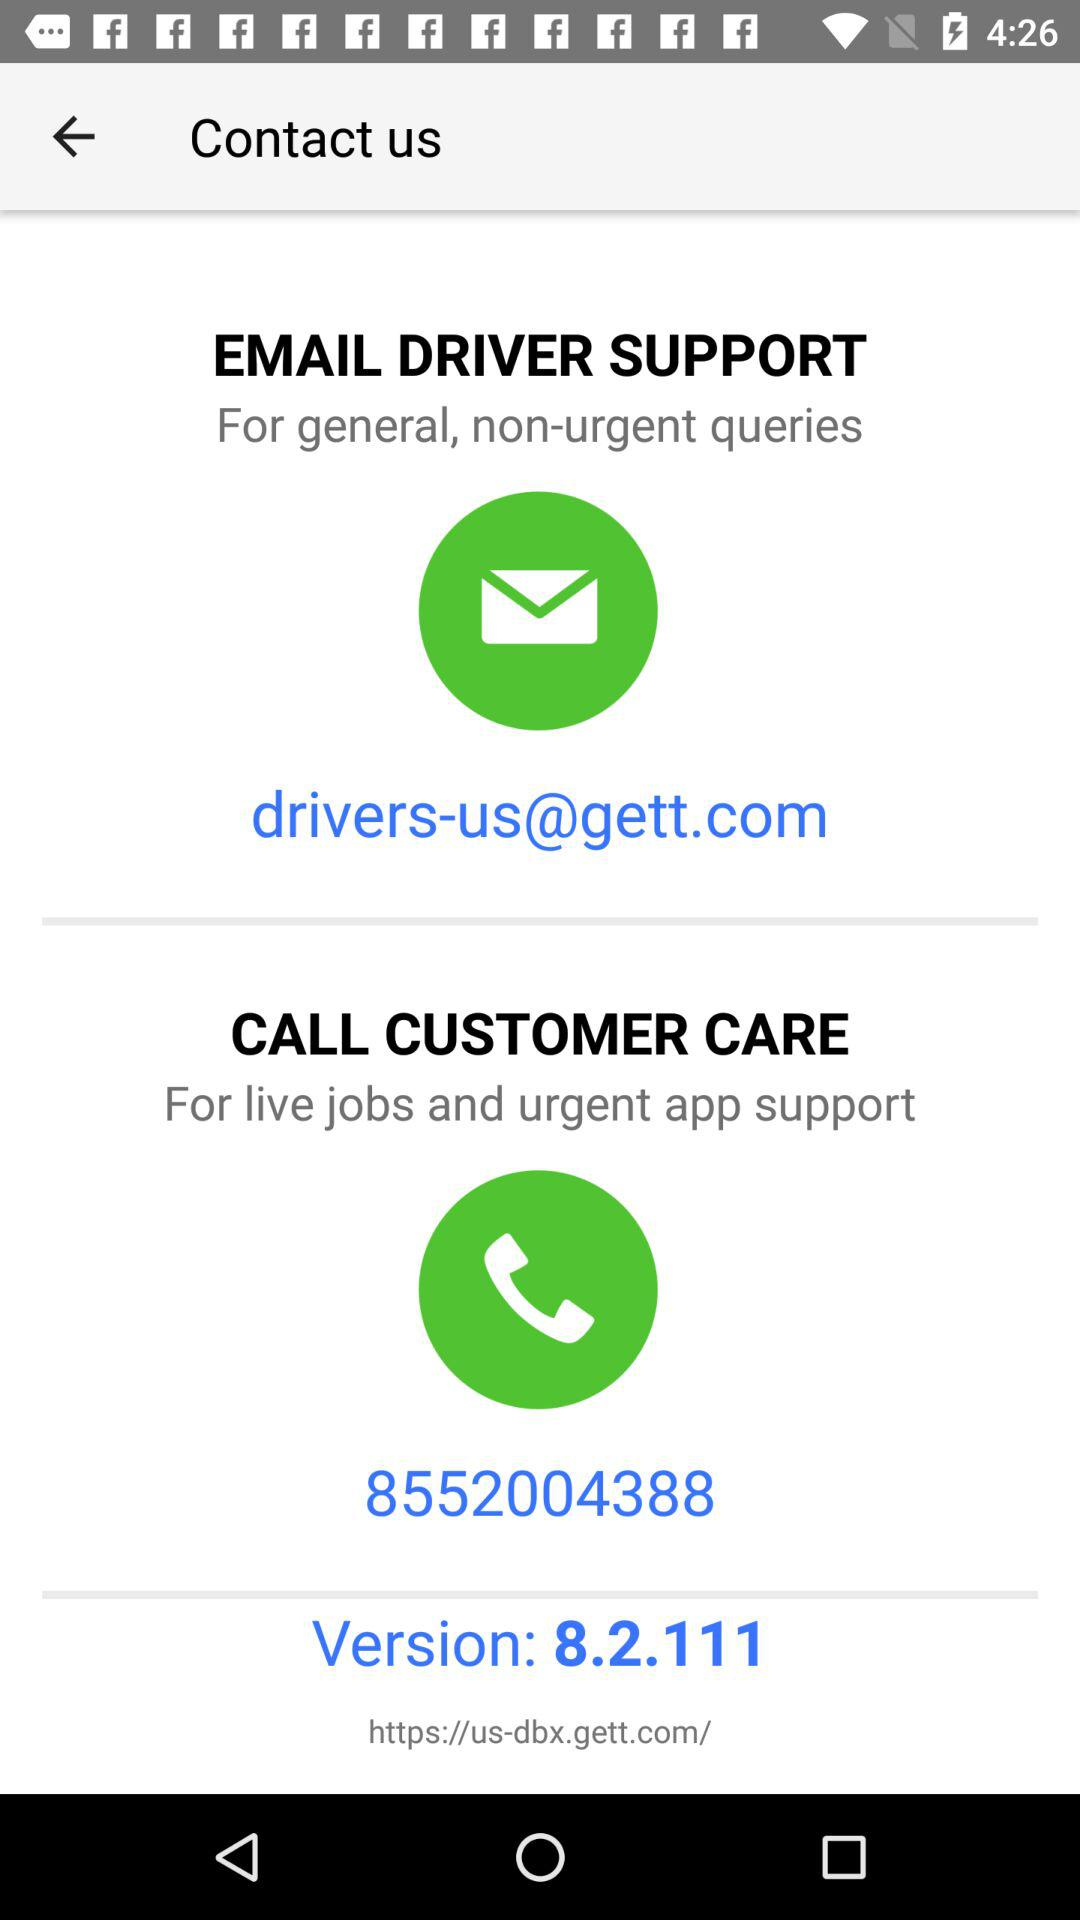What is the email address? The email address is drivers-us@gett.com. 